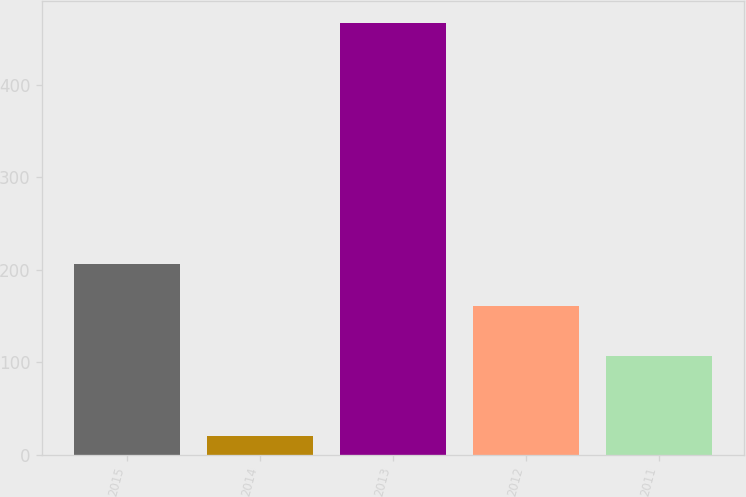Convert chart to OTSL. <chart><loc_0><loc_0><loc_500><loc_500><bar_chart><fcel>2015<fcel>2014<fcel>2013<fcel>2012<fcel>2011<nl><fcel>205.69<fcel>20.3<fcel>467.2<fcel>161<fcel>106.6<nl></chart> 